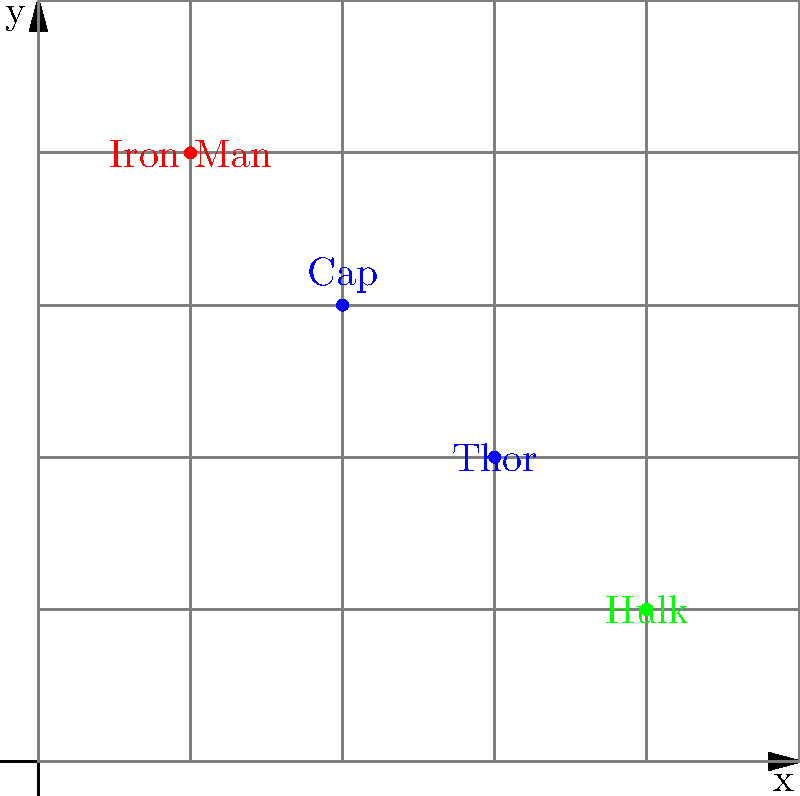Your child wants to recreate an Avengers battle scene using LEGO minifigures on a 5x5 grid. They've placed Iron Man at (1,4), Thor at (3,2), Hulk at (4,1), and Captain America at (2,3). If they want to add Black Widow at the midpoint between Iron Man and Thor, what coordinates should Black Widow be placed at? Let's solve this step-by-step:

1) First, we need to identify the coordinates of Iron Man and Thor:
   Iron Man: (1,4)
   Thor: (3,2)

2) To find the midpoint, we'll use the midpoint formula:
   $$(x_{\text{midpoint}}, y_{\text{midpoint}}) = (\frac{x_1 + x_2}{2}, \frac{y_1 + y_2}{2})$$

3) Let's substitute the values:
   $x_{\text{midpoint}} = \frac{1 + 3}{2} = \frac{4}{2} = 2$
   $y_{\text{midpoint}} = \frac{4 + 2}{2} = \frac{6}{2} = 3$

4) Therefore, the midpoint coordinates are (2,3).

5) However, we need to check if these coordinates are already occupied. Looking at the given information, we see that Captain America is already at (2,3).

6) Since (2,3) is occupied, we need to find the nearest available grid point. The closest unoccupied points are (2,4) or (2,2).

7) Given that Black Widow often works closely with Captain America, it makes sense to place her above him at (2,4).
Answer: (2,4) 